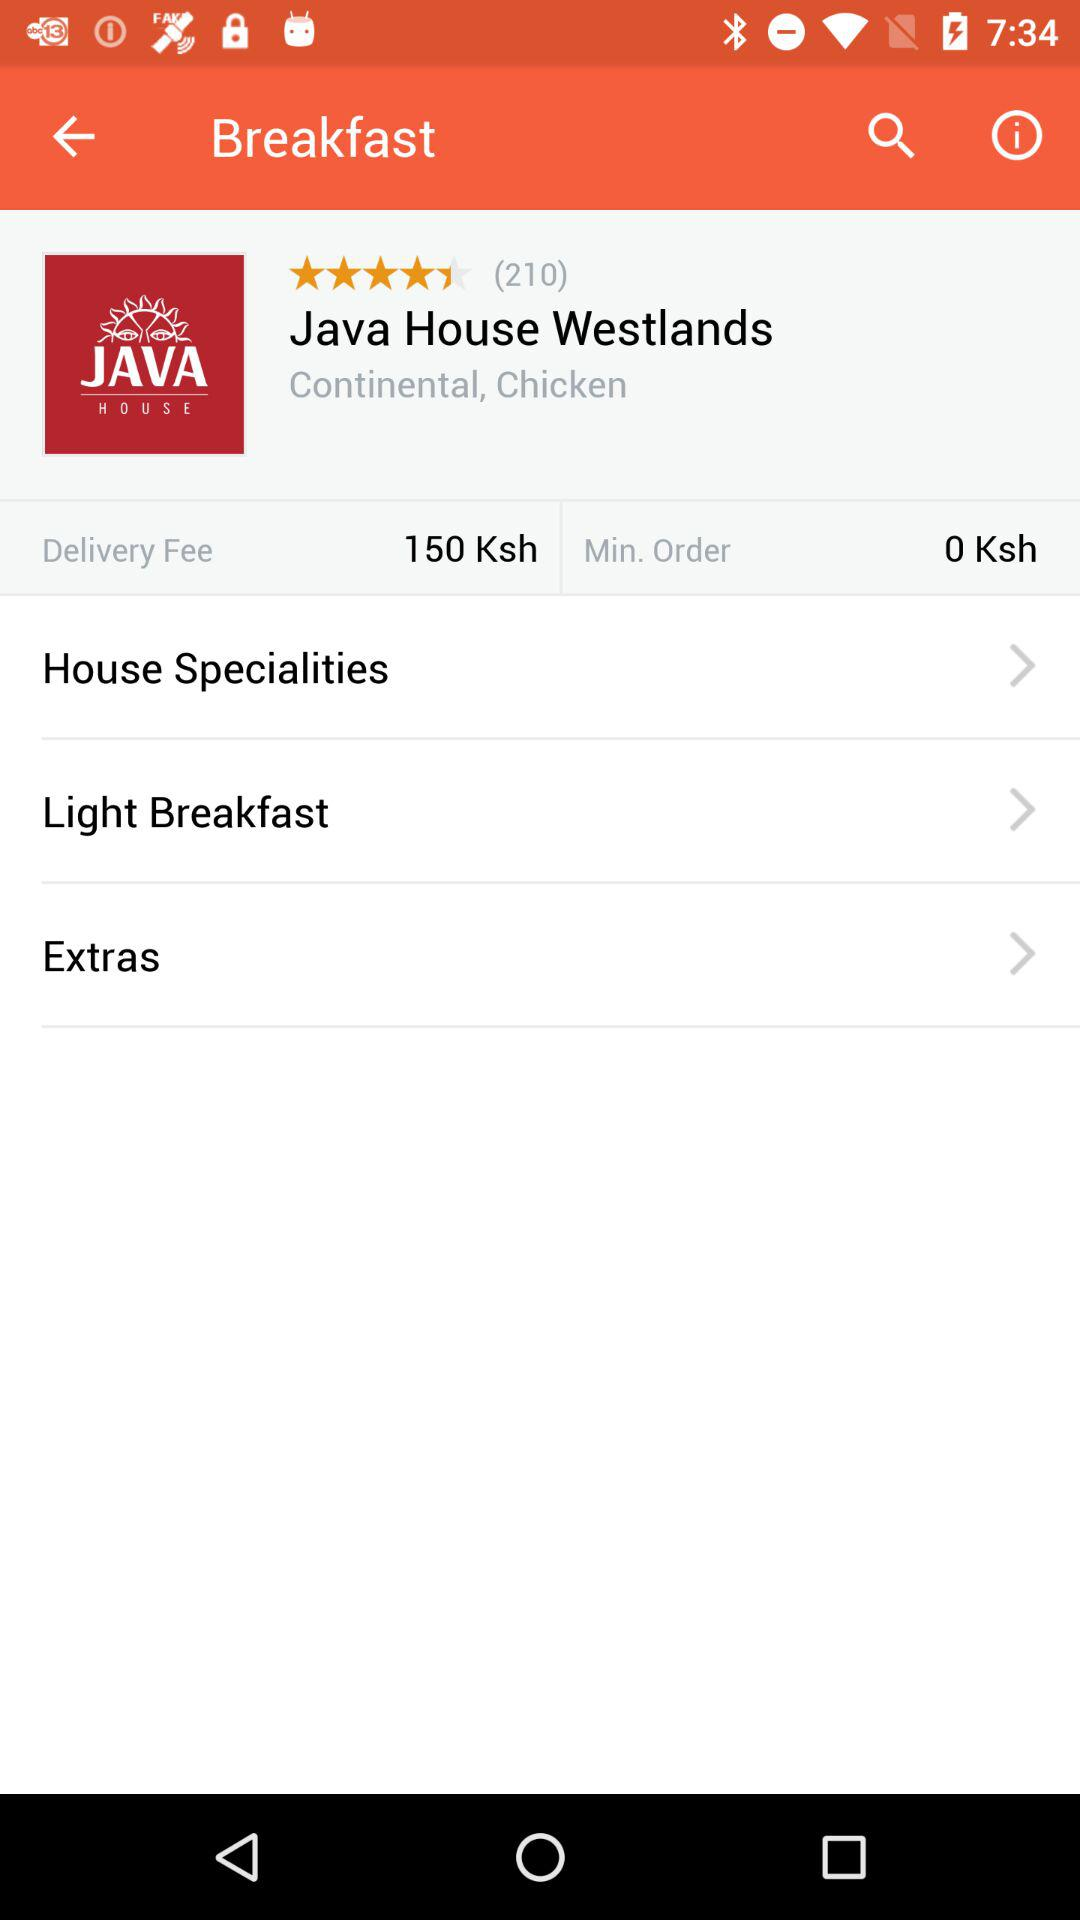What is the minimum order cost? The minimum order cost is 0 Ksh. 